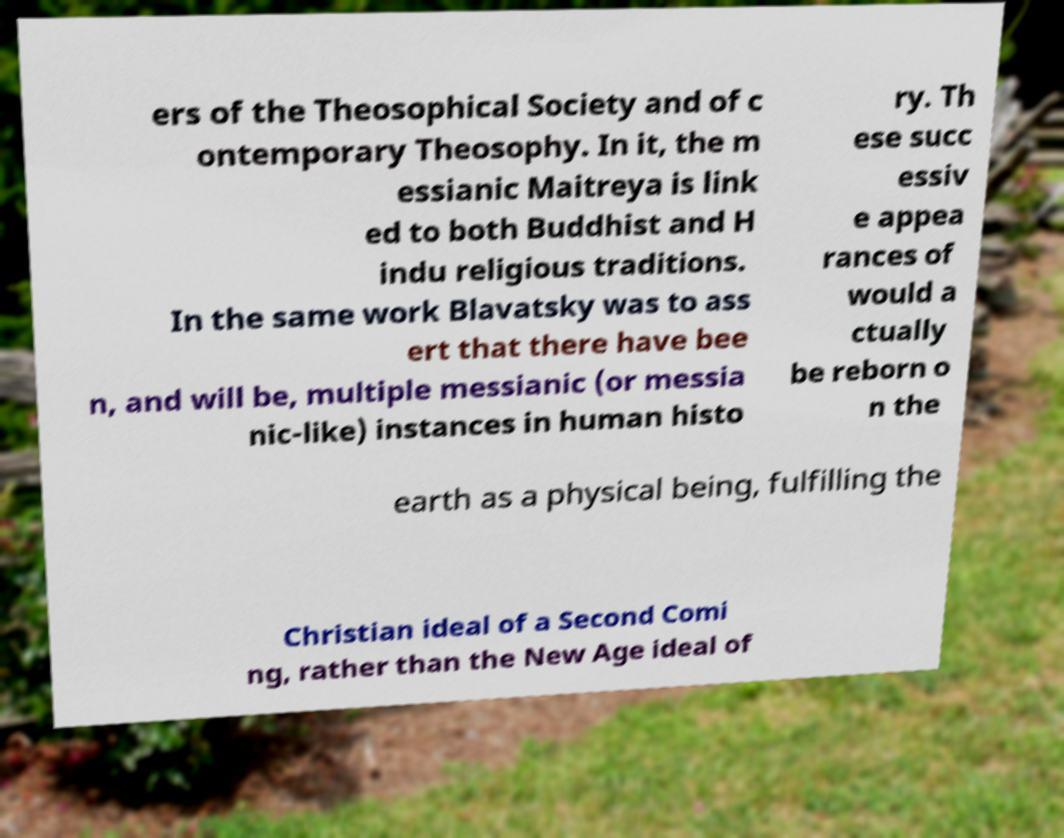Please read and relay the text visible in this image. What does it say? ers of the Theosophical Society and of c ontemporary Theosophy. In it, the m essianic Maitreya is link ed to both Buddhist and H indu religious traditions. In the same work Blavatsky was to ass ert that there have bee n, and will be, multiple messianic (or messia nic-like) instances in human histo ry. Th ese succ essiv e appea rances of would a ctually be reborn o n the earth as a physical being, fulfilling the Christian ideal of a Second Comi ng, rather than the New Age ideal of 